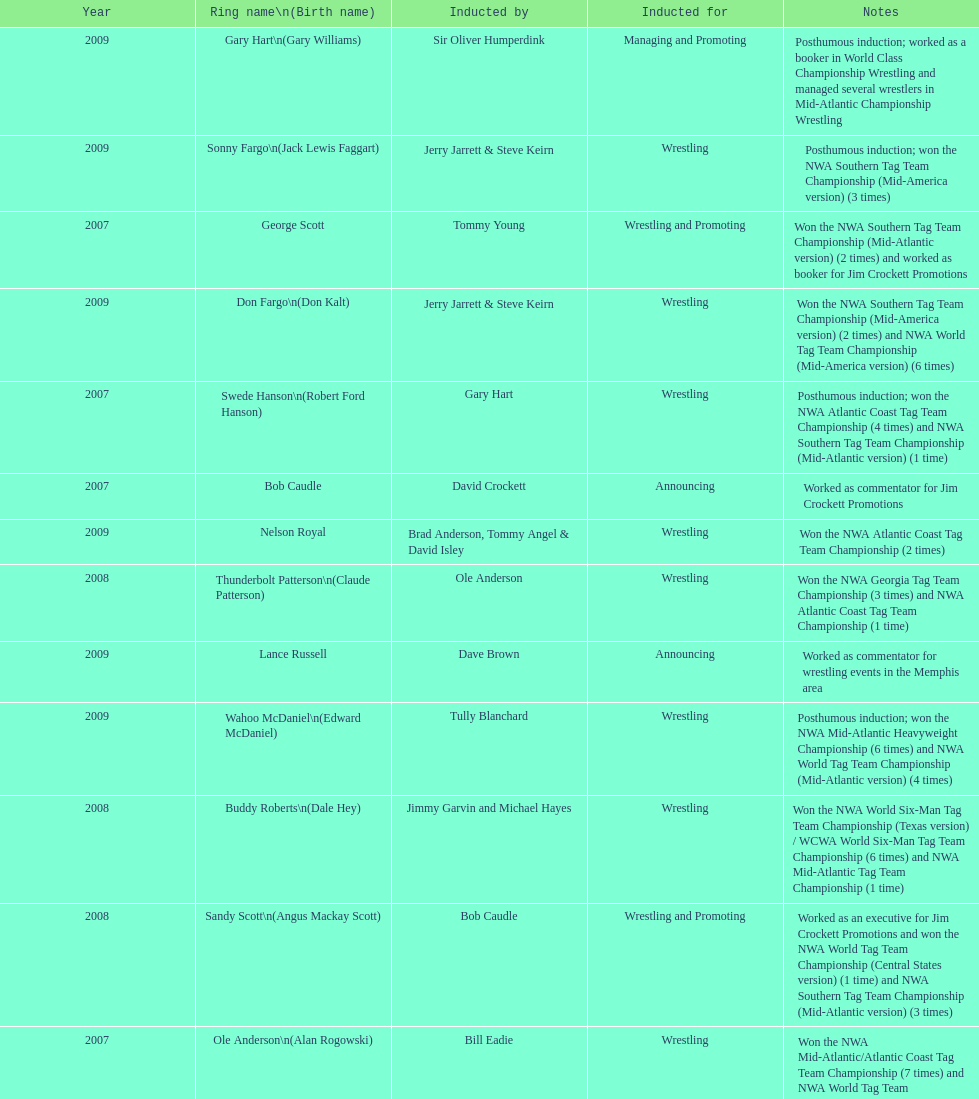Who won the most nwa southern tag team championships (mid-america version)? Jackie Fargo. 